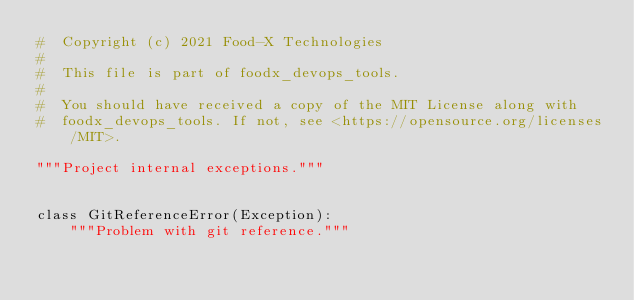<code> <loc_0><loc_0><loc_500><loc_500><_Python_>#  Copyright (c) 2021 Food-X Technologies
#
#  This file is part of foodx_devops_tools.
#
#  You should have received a copy of the MIT License along with
#  foodx_devops_tools. If not, see <https://opensource.org/licenses/MIT>.

"""Project internal exceptions."""


class GitReferenceError(Exception):
    """Problem with git reference."""
</code> 